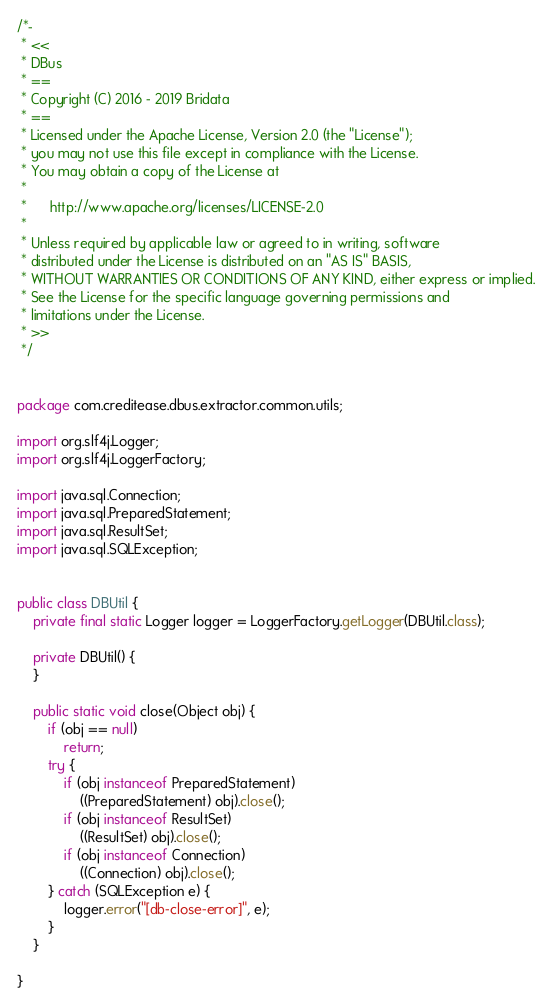<code> <loc_0><loc_0><loc_500><loc_500><_Java_>/*-
 * <<
 * DBus
 * ==
 * Copyright (C) 2016 - 2019 Bridata
 * ==
 * Licensed under the Apache License, Version 2.0 (the "License");
 * you may not use this file except in compliance with the License.
 * You may obtain a copy of the License at
 * 
 *      http://www.apache.org/licenses/LICENSE-2.0
 * 
 * Unless required by applicable law or agreed to in writing, software
 * distributed under the License is distributed on an "AS IS" BASIS,
 * WITHOUT WARRANTIES OR CONDITIONS OF ANY KIND, either express or implied.
 * See the License for the specific language governing permissions and
 * limitations under the License.
 * >>
 */


package com.creditease.dbus.extractor.common.utils;

import org.slf4j.Logger;
import org.slf4j.LoggerFactory;

import java.sql.Connection;
import java.sql.PreparedStatement;
import java.sql.ResultSet;
import java.sql.SQLException;


public class DBUtil {
    private final static Logger logger = LoggerFactory.getLogger(DBUtil.class);

    private DBUtil() {
    }

    public static void close(Object obj) {
        if (obj == null)
            return;
        try {
            if (obj instanceof PreparedStatement)
                ((PreparedStatement) obj).close();
            if (obj instanceof ResultSet)
                ((ResultSet) obj).close();
            if (obj instanceof Connection)
                ((Connection) obj).close();
        } catch (SQLException e) {
            logger.error("[db-close-error]", e);
        }
    }

}
</code> 